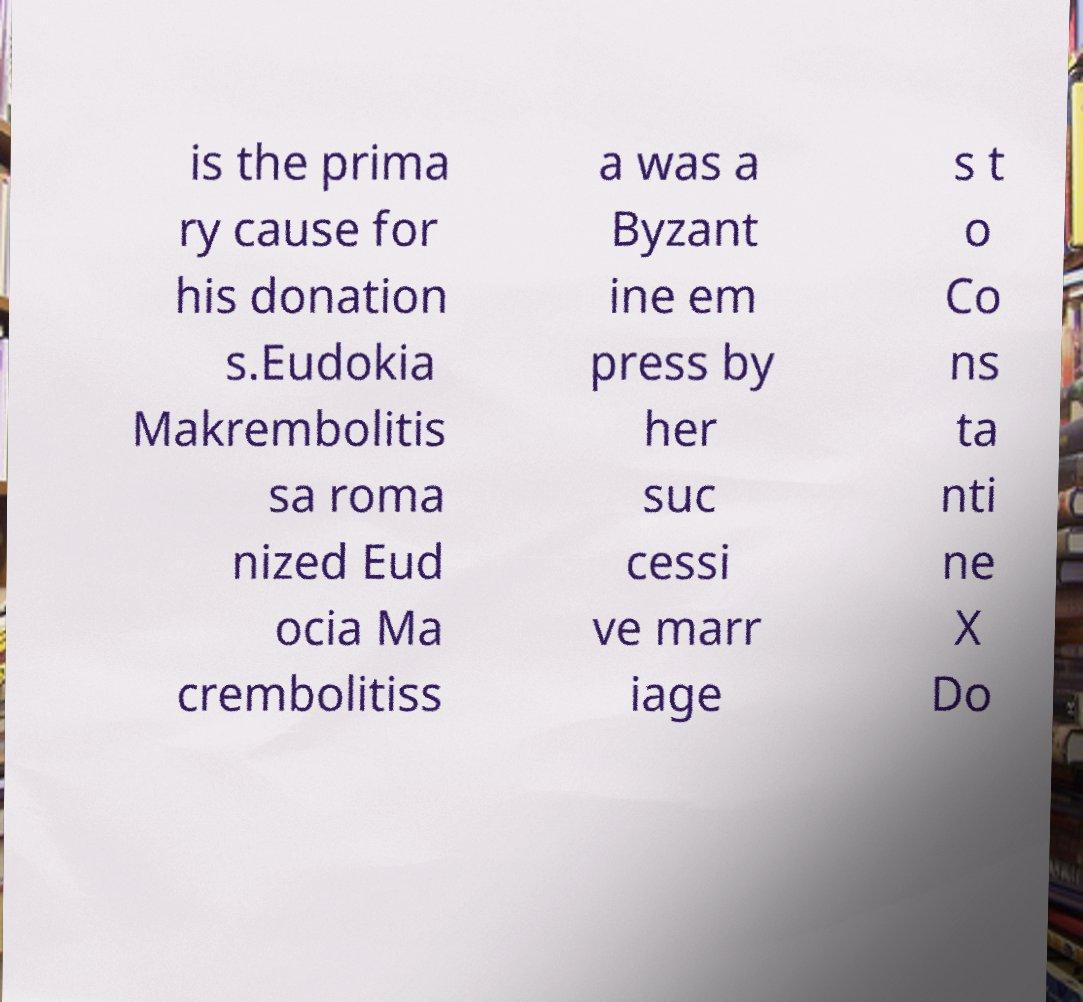Could you extract and type out the text from this image? is the prima ry cause for his donation s.Eudokia Makrembolitis sa roma nized Eud ocia Ma crembolitiss a was a Byzant ine em press by her suc cessi ve marr iage s t o Co ns ta nti ne X Do 